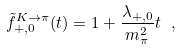<formula> <loc_0><loc_0><loc_500><loc_500>\tilde { f } ^ { K \rightarrow \pi } _ { + , 0 } ( t ) = 1 + \frac { \lambda _ { + , 0 } } { m _ { \pi } ^ { 2 } } t \ ,</formula> 